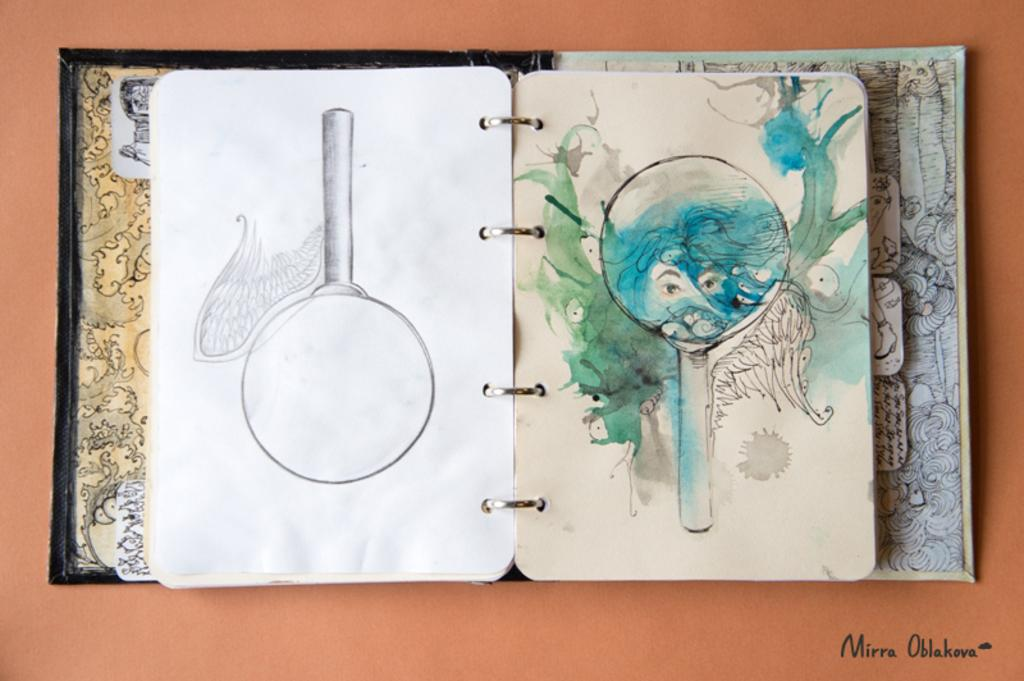What is the main object in the image? There is a book in the image. What type of content is in the book? The book contains pictures of cartoons. What type of furniture is depicted in the cartoon images in the book? The provided facts do not mention any furniture in the cartoon images, so we cannot answer that question. 